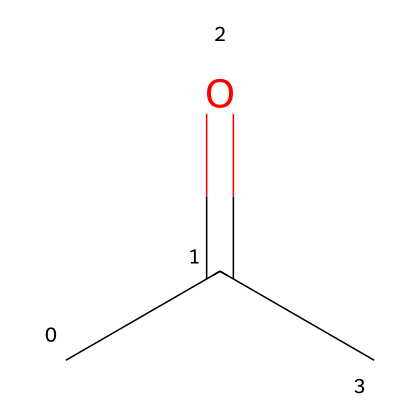What is the name of this chemical? The SMILES representation CC(=O)C corresponds to a molecule known as acetone, which is a common solvent.
Answer: acetone How many carbon atoms are present in this molecule? From the structure CC(=O)C, we can identify that there are three carbon atoms in total, represented by the 'C' symbols and the carbonyl group.
Answer: three What type of functional group is present in this molecule? In the SMILES, the presence of the carbonyl group (C=O) indicates that this molecule contains a ketone functional group.
Answer: ketone How many hydrogen atoms are in acetone? By analyzing the structure CC(=O)C, we see that there are six hydrogen atoms connected to the three carbon atoms following standard valency rules: each carbon typically forms four bonds.
Answer: six What is the primary use of acetone in relation to antique instruments? Acetone is primarily used as a solvent to remove varnish from antique instruments due to its effective ability to dissolve resin and paint.
Answer: varnish removal Is acetone a polar or non-polar solvent? The presence of the carbonyl group in the structure indicates that acetone has polar characteristics, making it a polar solvent.
Answer: polar What would happen if acetone is mixed with water? Acetone is miscible with water, meaning it can mix in any proportion, effectively forming a homogeneous solution.
Answer: miscible 